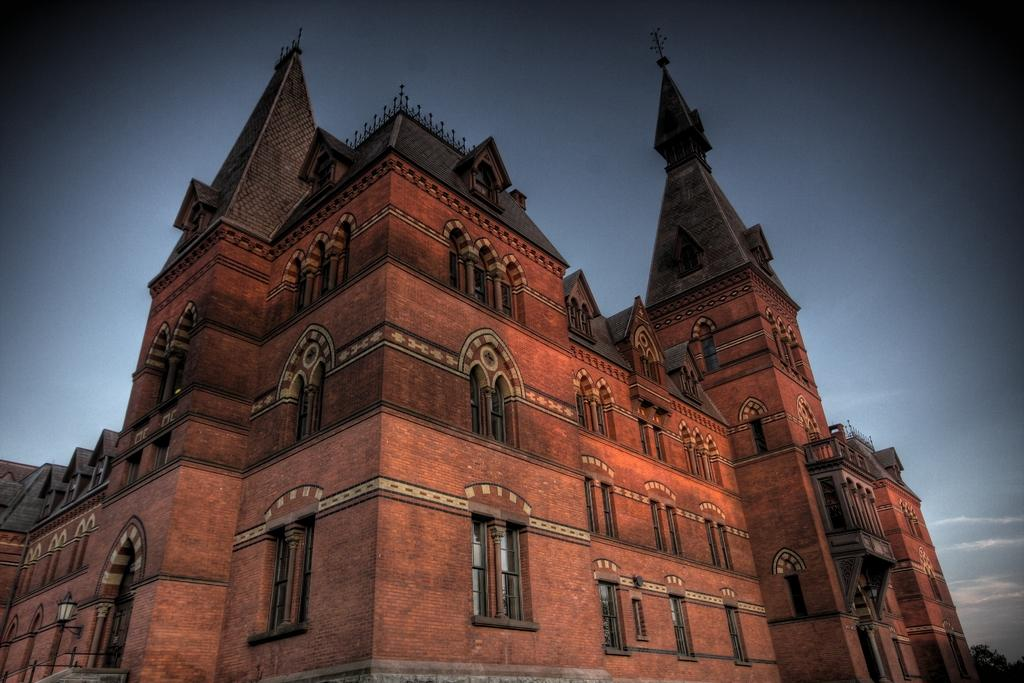What structure is the main subject of the picture? There is a building in the picture. What can be seen at the top of the picture? The sky is visible at the top of the picture. What feature can be observed on the building? There are windows on the building. What type of vegetation is present at the right bottom of the picture? There appears to be a tree at the right bottom of the picture. Can you tell me how many cherries are on the tree in the picture? There is no tree with cherries present in the image; it features a tree without any visible fruit. Is the friend of the person who took the picture visible in the image? There is no person or friend visible in the image; it only features a building, the sky, windows, and a tree. 